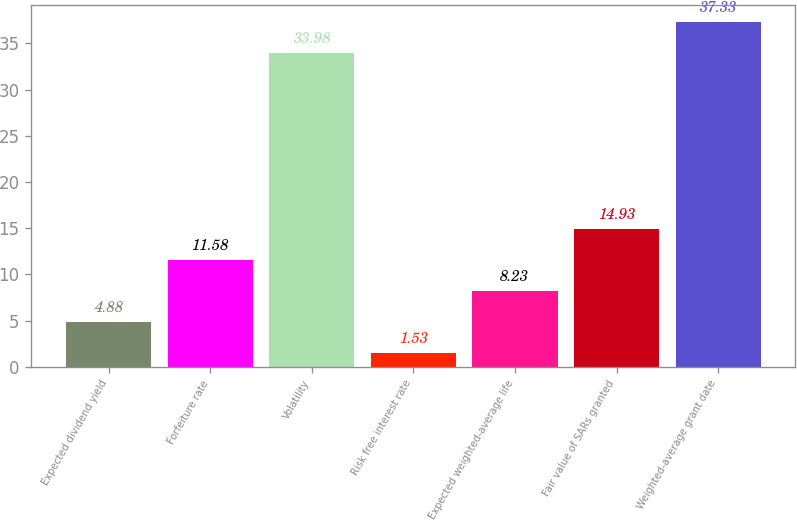Convert chart. <chart><loc_0><loc_0><loc_500><loc_500><bar_chart><fcel>Expected dividend yield<fcel>Forfeiture rate<fcel>Volatility<fcel>Risk free interest rate<fcel>Expected weighted-average life<fcel>Fair value of SARs granted<fcel>Weighted-average grant date<nl><fcel>4.88<fcel>11.58<fcel>33.98<fcel>1.53<fcel>8.23<fcel>14.93<fcel>37.33<nl></chart> 